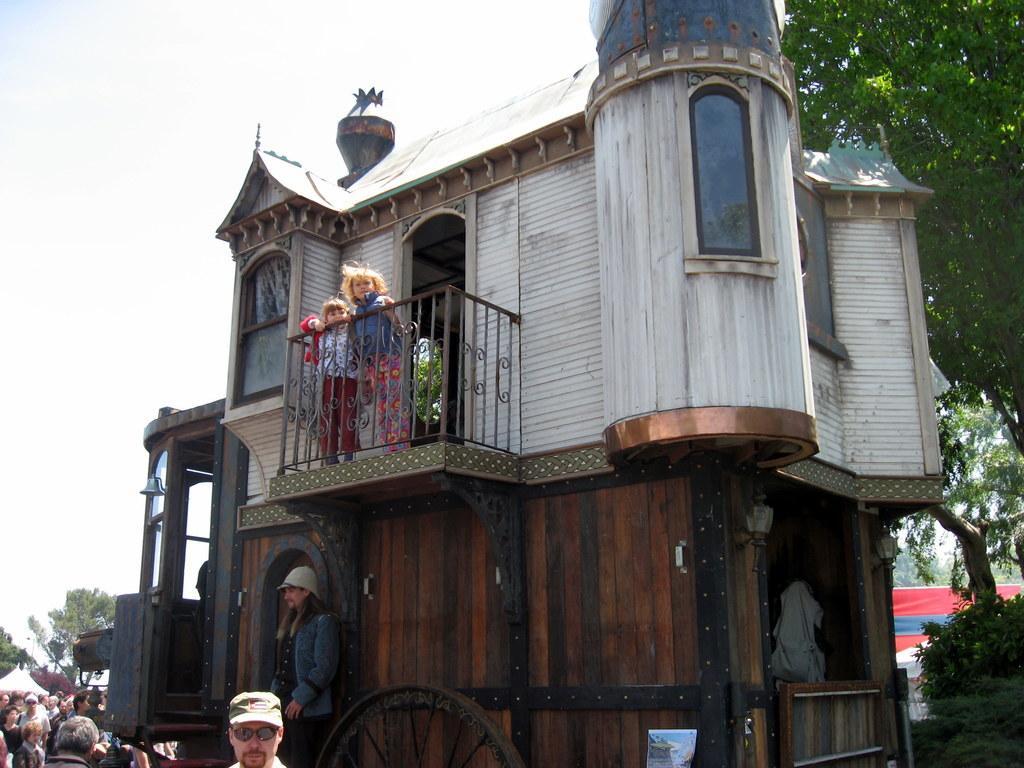In one or two sentences, can you explain what this image depicts? In this picture we can see a building here, at the left bottom there are some people standing, we can see a tree here, there is a balcony and railing here, there is the sky at the top of the picture. 